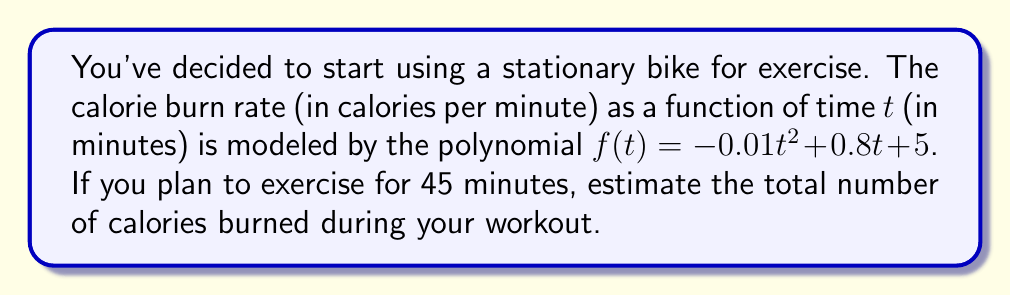Solve this math problem. To solve this problem, we need to find the integral of the calorie burn rate function over the time interval [0, 45]. This will give us the total calories burned.

Step 1: Set up the integral
$$\text{Total Calories} = \int_0^{45} f(t) dt = \int_0^{45} (-0.01t^2 + 0.8t + 5) dt$$

Step 2: Integrate the polynomial term by term
$$\int (-0.01t^2 + 0.8t + 5) dt = -\frac{0.01}{3}t^3 + 0.4t^2 + 5t + C$$

Step 3: Apply the limits of integration
$$\text{Total Calories} = \left[-\frac{0.01}{3}t^3 + 0.4t^2 + 5t\right]_0^{45}$$

Step 4: Evaluate the function at t = 45 and t = 0
$$\begin{align*}
\text{At t = 45:} &\quad -\frac{0.01}{3}(45^3) + 0.4(45^2) + 5(45) = -303.75 + 810 + 225 = 731.25 \\
\text{At t = 0:} &\quad 0
\end{align*}$$

Step 5: Subtract to get the final result
$$731.25 - 0 = 731.25$$

Therefore, you would burn approximately 731.25 calories during your 45-minute workout.
Answer: 731.25 calories 